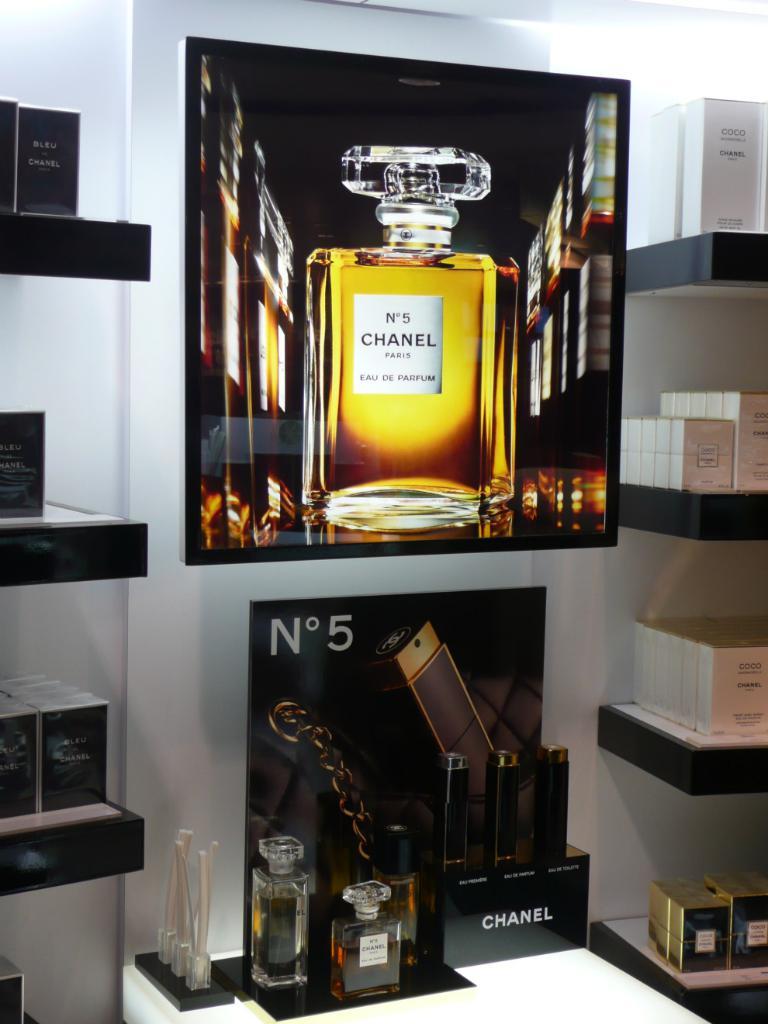What is the brand of perfume on display?
Keep it short and to the point. Chanel. What "no" is showing?
Your response must be concise. 5. 